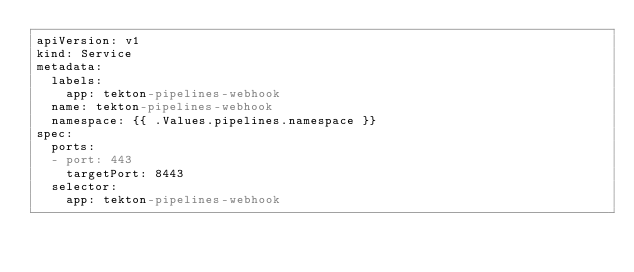Convert code to text. <code><loc_0><loc_0><loc_500><loc_500><_YAML_>apiVersion: v1
kind: Service
metadata:
  labels:
    app: tekton-pipelines-webhook
  name: tekton-pipelines-webhook
  namespace: {{ .Values.pipelines.namespace }}
spec:
  ports:
  - port: 443
    targetPort: 8443
  selector:
    app: tekton-pipelines-webhook</code> 